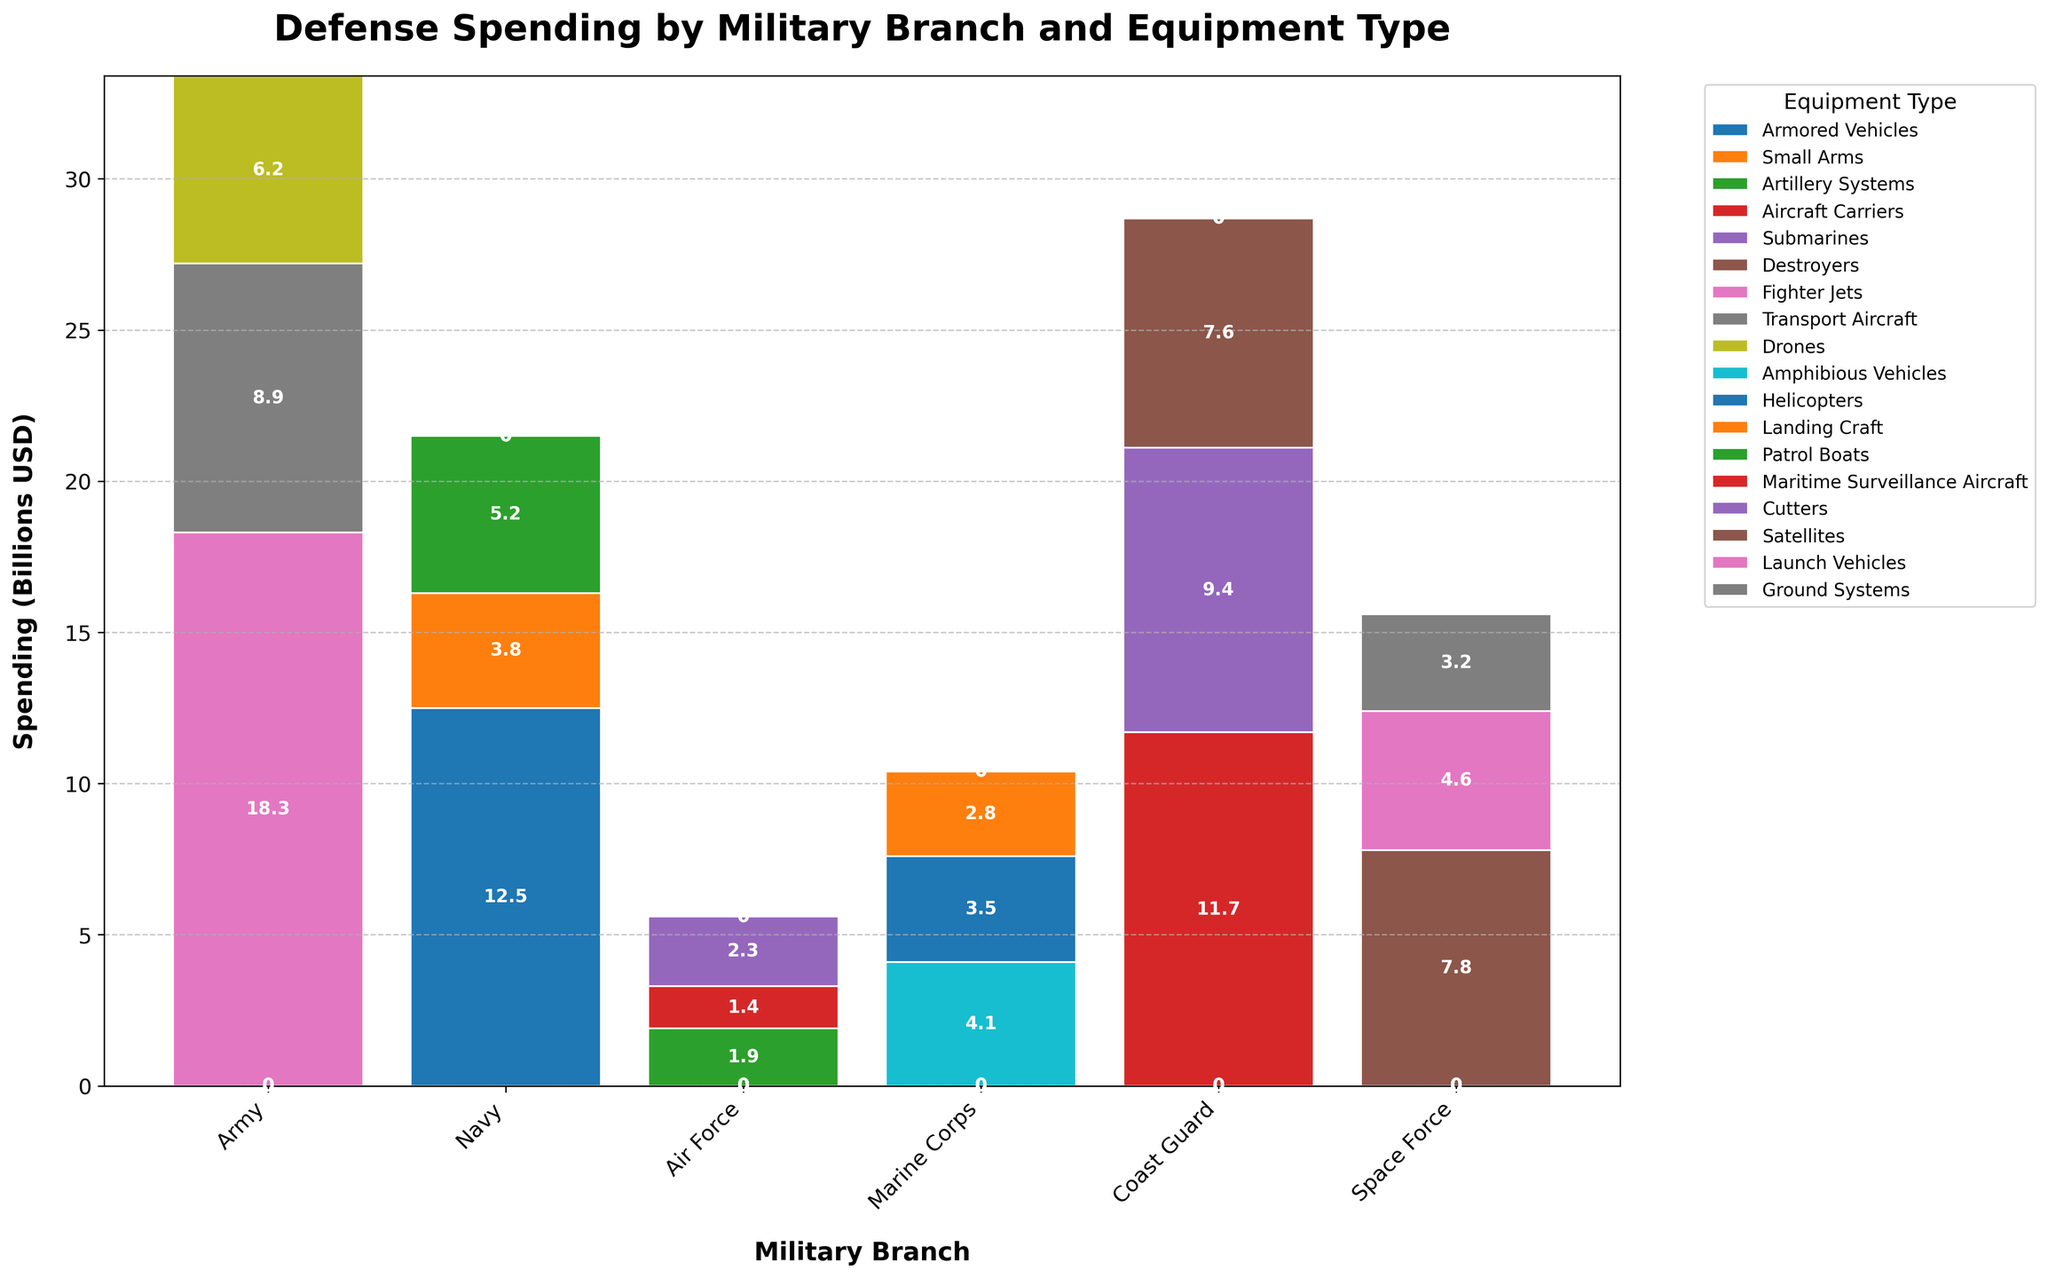What is the total defense spending for the Army? Add the spending for all the equipment types in the Army: 12.5 (Armored Vehicles) + 3.8 (Small Arms) + 5.2 (Artillery Systems) = 21.5
Answer: 21.5 Which military branch has the highest spending on a single equipment type, and what is it? Compare the highest spending values for each branch: Army (12.5 on Armored Vehicles), Navy (11.7 on Aircraft Carriers), Air Force (18.3 on Fighter Jets), Marine Corps (4.1 on Amphibious Vehicles), Coast Guard (2.3 on Cutters), Space Force (7.8 on Satellites). Air Force spends the most on Fighter Jets at 18.3.
Answer: Air Force, 18.3 How does the Navy's total spending compare to the Marine Corps' total spending? Add the spending for each equipment type in the Navy and Marine Corps and compare: Navy: 11.7 (Aircraft Carriers) + 9.4 (Submarines) + 7.6 (Destroyers) = 28.7. Marine Corps: 4.1 (Amphibious Vehicles) + 3.5 (Helicopters) + 2.8 (Landing Craft) = 10.4. The Navy spends more.
Answer: Navy spends more What is the difference between the spending on Fighter Jets by the Air Force and Aircraft Carriers by the Navy? Subtract the spending on Aircraft Carriers by the Navy from the spending on Fighter Jets by the Air Force: 18.3 (Fighter Jets) - 11.7 (Aircraft Carriers) = 6.6
Answer: 6.6 What is the average spending on equipment types for the Coast Guard? Add the spending on all equipment types for the Coast Guard and divide by the number of equipment types: 1.9 (Patrol Boats) + 1.4 (Maritime Surveillance Aircraft) + 2.3 (Cutters) = 5.6. 5.6 / 3 = 1.87
Answer: 1.87 Which equipment type has the lowest spending across all military branches, and how much is it? Compare spending for each equipment type across all branches and find the lowest: 1.4 (Maritime Surveillance Aircraft for Coast Guard) is the lowest.
Answer: Maritime Surveillance Aircraft, 1.4 How many branches spend more than 5 billion USD on a single equipment type? Check each branch's spending on single equipment types: Army (Armored Vehicles, Artillery Systems), Navy (Aircraft Carriers, Submarines, Destroyers), Air Force (Fighter Jets, Transport Aircraft, Drones), Marine Corps, Coast Guard, Space Force (Satellites, Launch Vehicles). The Army, Navy, Air Force, and Space Force each have spending greater than 5 billion on at least one equipment type.
Answer: 4 Which two branches have the closest total spending amounts and what are those amounts? Calculate the total spending for each branch and compare: Army (21.5), Navy (28.7), Air Force (33.4), Marine Corps (10.4), Coast Guard (5.6), Space Force (15.6). The closest are Marine Corps (10.4) and Space Force (15.6).
Answer: Marine Corps: 10.4, Space Force: 15.6 